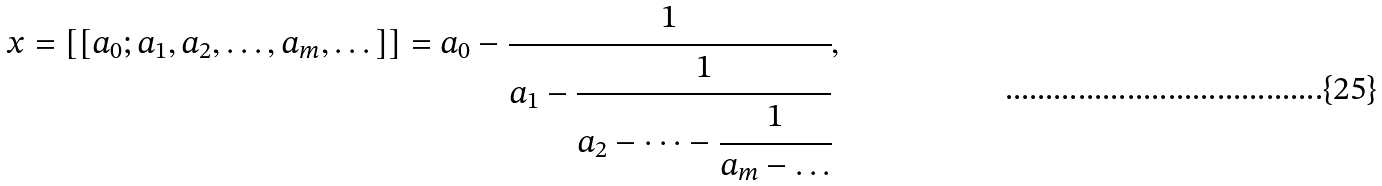Convert formula to latex. <formula><loc_0><loc_0><loc_500><loc_500>x = [ [ a _ { 0 } ; a _ { 1 } , a _ { 2 } , \dots , a _ { m } , \dots ] ] = a _ { 0 } - \cfrac { 1 } { a _ { 1 } - \cfrac { 1 } { a _ { 2 } - \dots - \cfrac { 1 } { a _ { m } - \dots } } } ,</formula> 